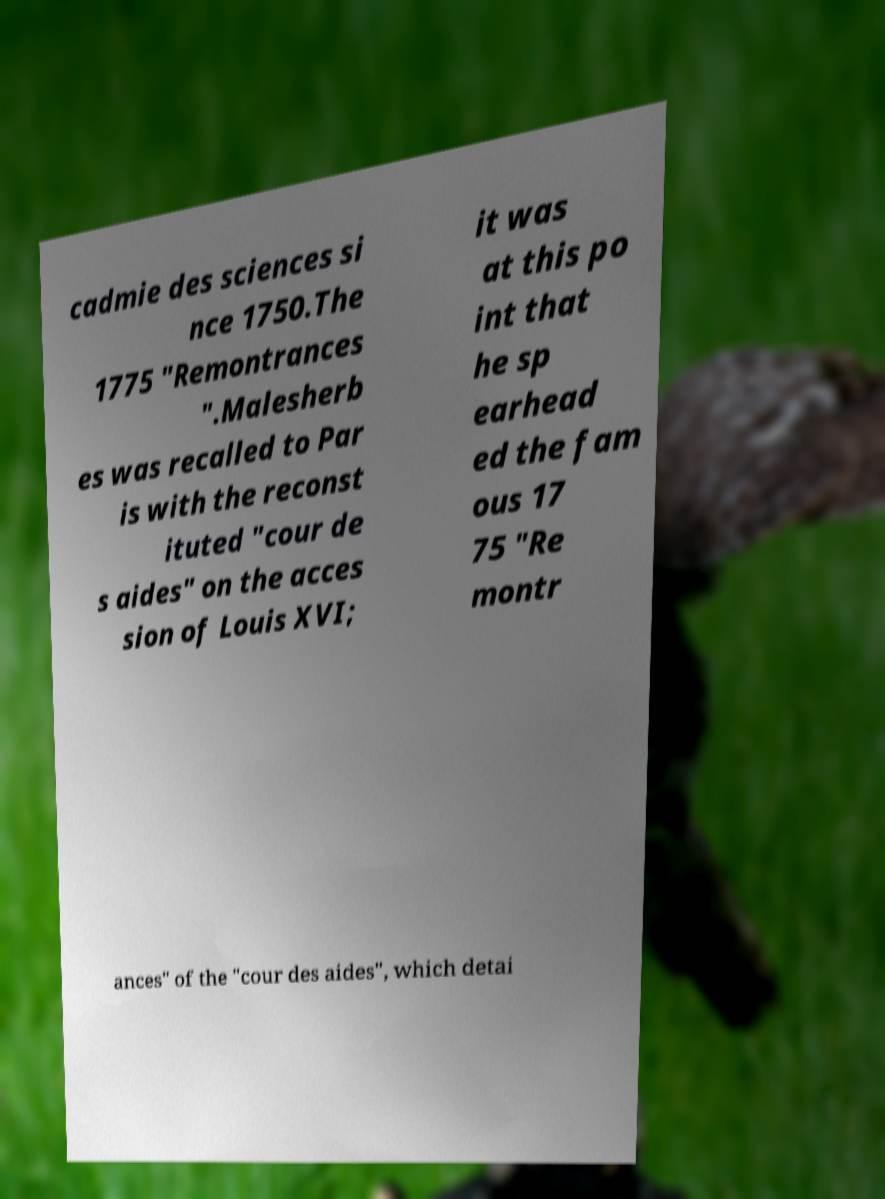Could you extract and type out the text from this image? cadmie des sciences si nce 1750.The 1775 "Remontrances ".Malesherb es was recalled to Par is with the reconst ituted "cour de s aides" on the acces sion of Louis XVI; it was at this po int that he sp earhead ed the fam ous 17 75 "Re montr ances" of the "cour des aides", which detai 